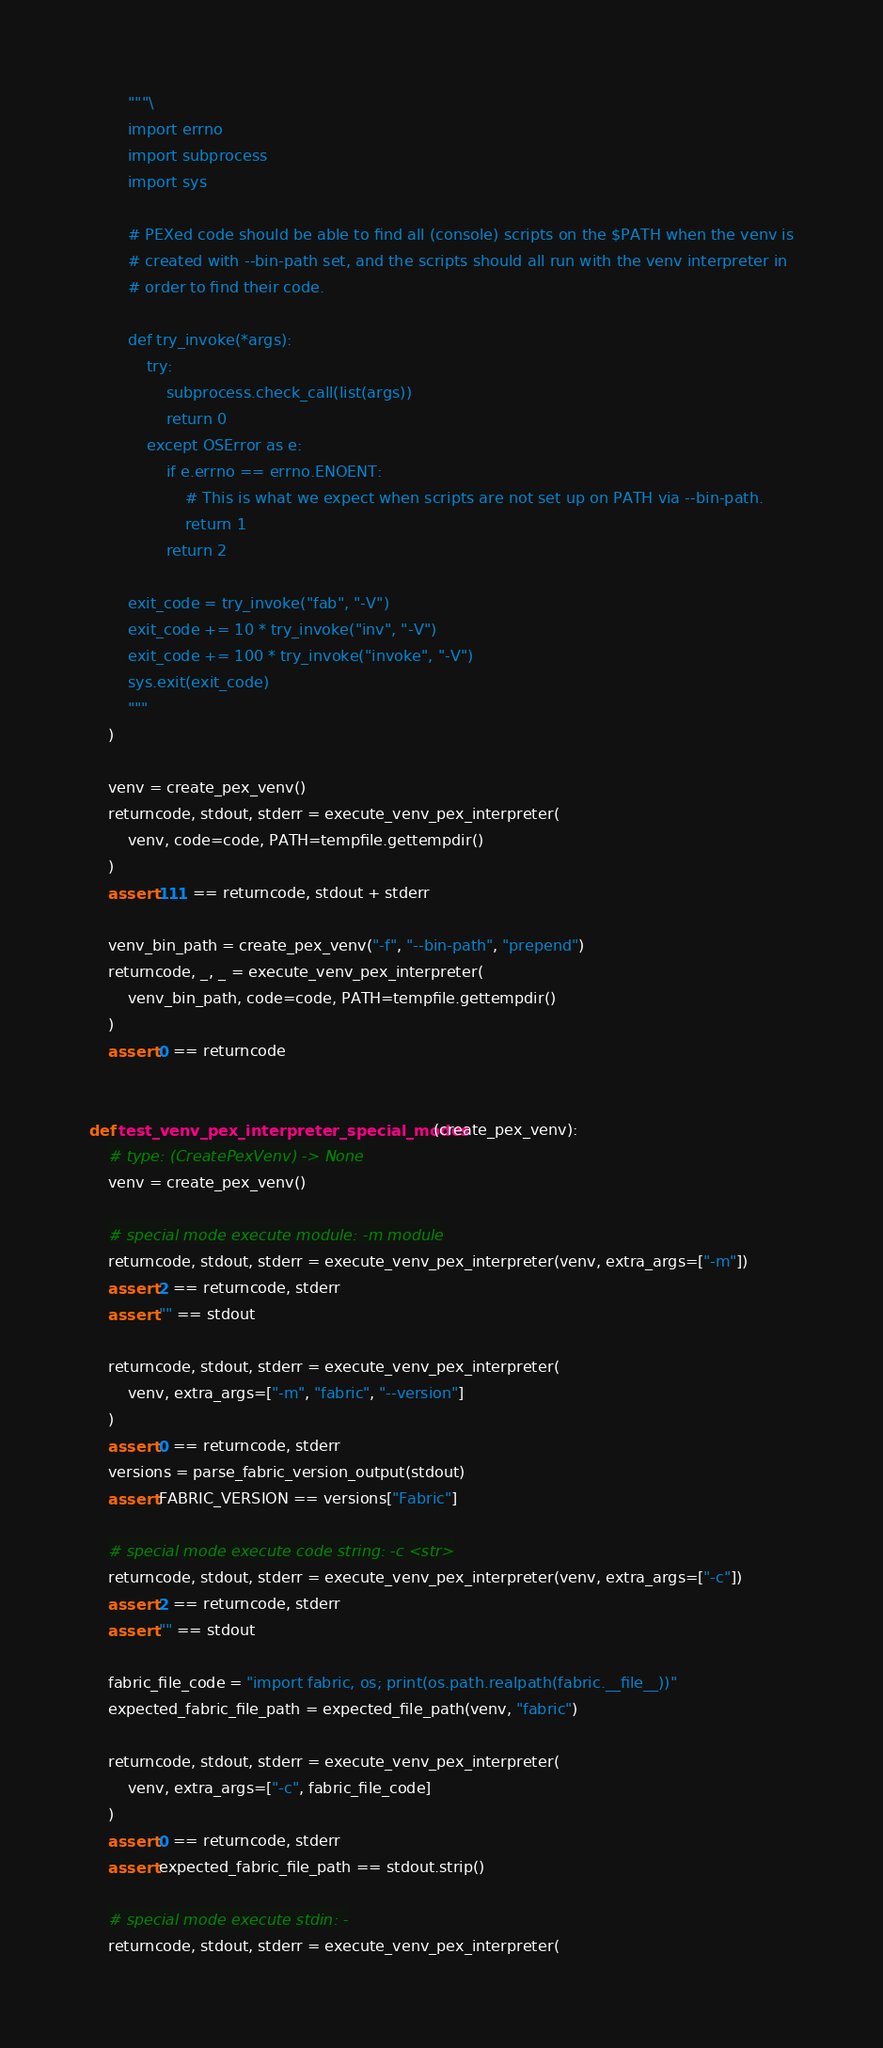Convert code to text. <code><loc_0><loc_0><loc_500><loc_500><_Python_>        """\
        import errno
        import subprocess
        import sys

        # PEXed code should be able to find all (console) scripts on the $PATH when the venv is
        # created with --bin-path set, and the scripts should all run with the venv interpreter in
        # order to find their code.

        def try_invoke(*args):
            try:
                subprocess.check_call(list(args))
                return 0
            except OSError as e:
                if e.errno == errno.ENOENT:
                    # This is what we expect when scripts are not set up on PATH via --bin-path.
                    return 1
                return 2

        exit_code = try_invoke("fab", "-V")
        exit_code += 10 * try_invoke("inv", "-V")
        exit_code += 100 * try_invoke("invoke", "-V")
        sys.exit(exit_code)
        """
    )

    venv = create_pex_venv()
    returncode, stdout, stderr = execute_venv_pex_interpreter(
        venv, code=code, PATH=tempfile.gettempdir()
    )
    assert 111 == returncode, stdout + stderr

    venv_bin_path = create_pex_venv("-f", "--bin-path", "prepend")
    returncode, _, _ = execute_venv_pex_interpreter(
        venv_bin_path, code=code, PATH=tempfile.gettempdir()
    )
    assert 0 == returncode


def test_venv_pex_interpreter_special_modes(create_pex_venv):
    # type: (CreatePexVenv) -> None
    venv = create_pex_venv()

    # special mode execute module: -m module
    returncode, stdout, stderr = execute_venv_pex_interpreter(venv, extra_args=["-m"])
    assert 2 == returncode, stderr
    assert "" == stdout

    returncode, stdout, stderr = execute_venv_pex_interpreter(
        venv, extra_args=["-m", "fabric", "--version"]
    )
    assert 0 == returncode, stderr
    versions = parse_fabric_version_output(stdout)
    assert FABRIC_VERSION == versions["Fabric"]

    # special mode execute code string: -c <str>
    returncode, stdout, stderr = execute_venv_pex_interpreter(venv, extra_args=["-c"])
    assert 2 == returncode, stderr
    assert "" == stdout

    fabric_file_code = "import fabric, os; print(os.path.realpath(fabric.__file__))"
    expected_fabric_file_path = expected_file_path(venv, "fabric")

    returncode, stdout, stderr = execute_venv_pex_interpreter(
        venv, extra_args=["-c", fabric_file_code]
    )
    assert 0 == returncode, stderr
    assert expected_fabric_file_path == stdout.strip()

    # special mode execute stdin: -
    returncode, stdout, stderr = execute_venv_pex_interpreter(</code> 